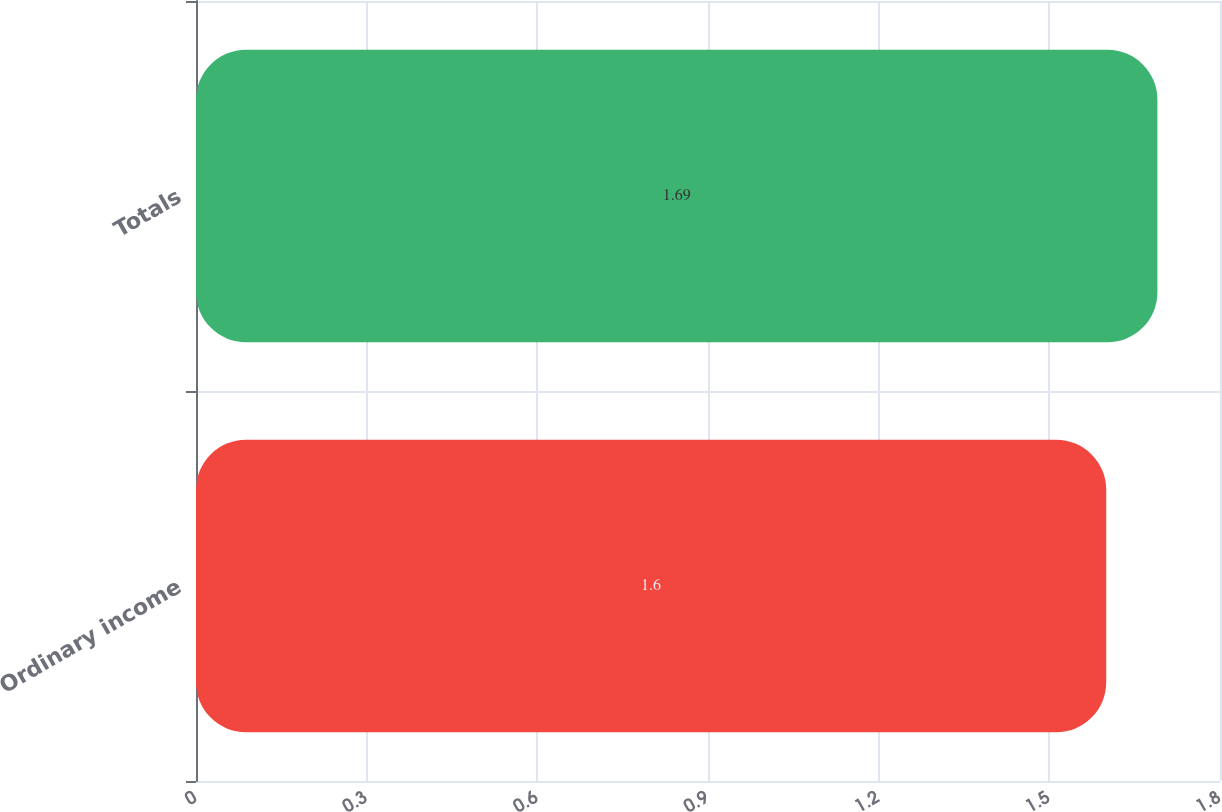Convert chart. <chart><loc_0><loc_0><loc_500><loc_500><bar_chart><fcel>Ordinary income<fcel>Totals<nl><fcel>1.6<fcel>1.69<nl></chart> 